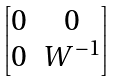Convert formula to latex. <formula><loc_0><loc_0><loc_500><loc_500>\begin{bmatrix} 0 & 0 \\ 0 & W ^ { - 1 } \end{bmatrix}</formula> 